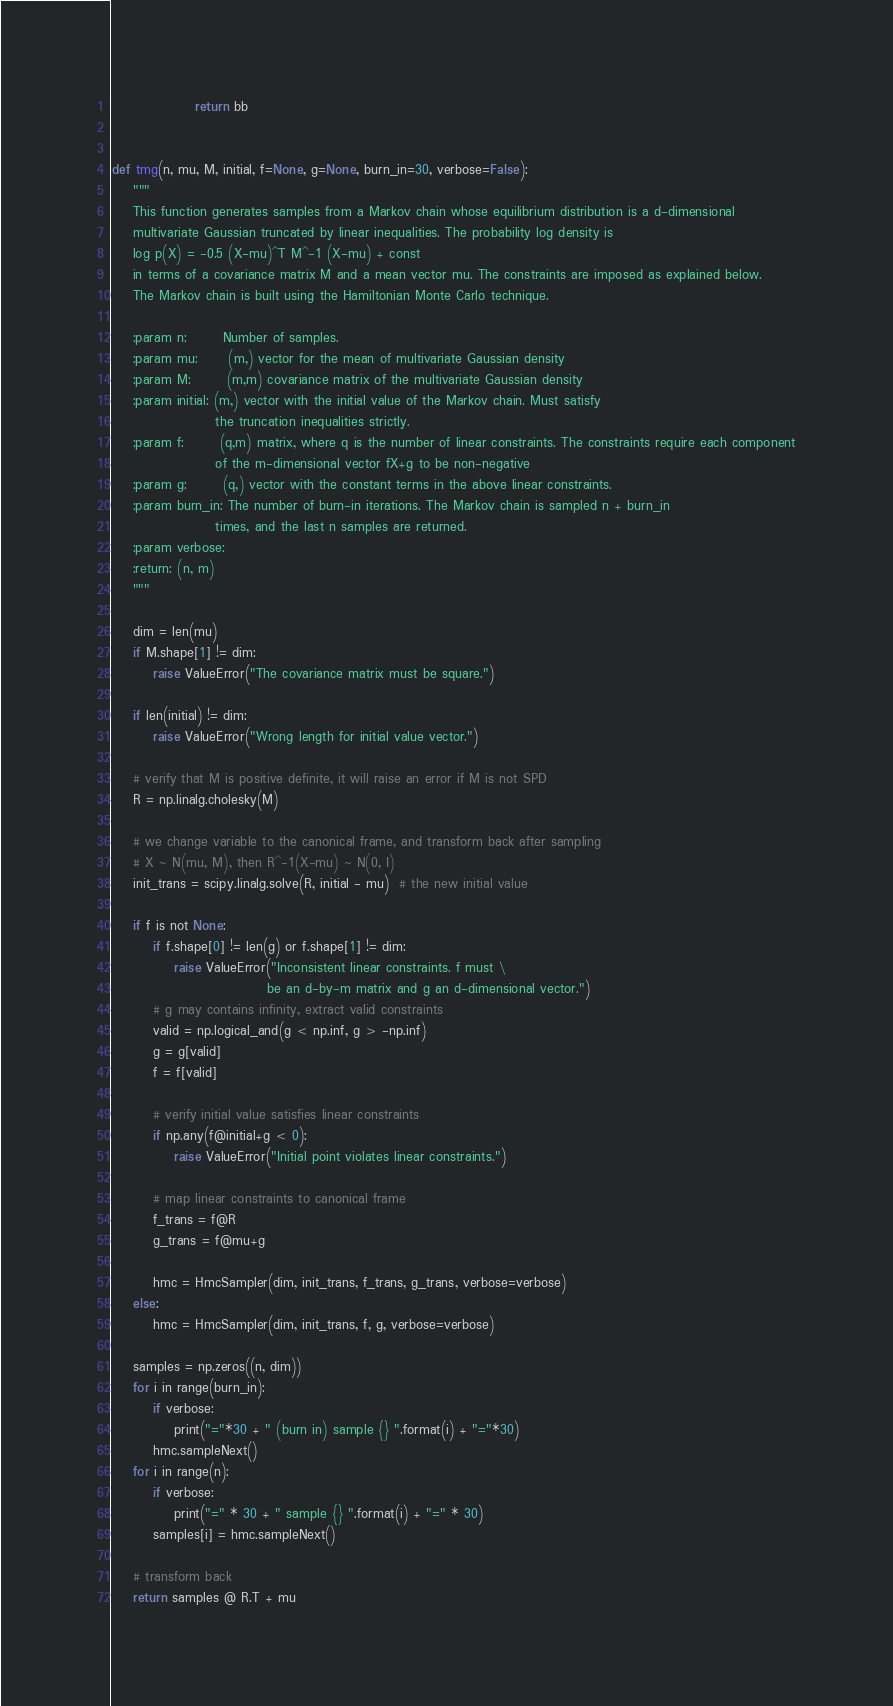<code> <loc_0><loc_0><loc_500><loc_500><_Python_>                return bb


def tmg(n, mu, M, initial, f=None, g=None, burn_in=30, verbose=False):
    """
    This function generates samples from a Markov chain whose equilibrium distribution is a d-dimensional
    multivariate Gaussian truncated by linear inequalities. The probability log density is
    log p(X) = -0.5 (X-mu)^T M^-1 (X-mu) + const
    in terms of a covariance matrix M and a mean vector mu. The constraints are imposed as explained below.
    The Markov chain is built using the Hamiltonian Monte Carlo technique.

    :param n:       Number of samples.
    :param mu:      (m,) vector for the mean of multivariate Gaussian density
    :param M:       (m,m) covariance matrix of the multivariate Gaussian density
    :param initial: (m,) vector with the initial value of the Markov chain. Must satisfy
                    the truncation inequalities strictly.
    :param f:       (q,m) matrix, where q is the number of linear constraints. The constraints require each component
                    of the m-dimensional vector fX+g to be non-negative
    :param g:       (q,) vector with the constant terms in the above linear constraints.
    :param burn_in: The number of burn-in iterations. The Markov chain is sampled n + burn_in
                    times, and the last n samples are returned.
    :param verbose:
    :return: (n, m)
    """

    dim = len(mu)
    if M.shape[1] != dim:
        raise ValueError("The covariance matrix must be square.")

    if len(initial) != dim:
        raise ValueError("Wrong length for initial value vector.")

    # verify that M is positive definite, it will raise an error if M is not SPD
    R = np.linalg.cholesky(M)

    # we change variable to the canonical frame, and transform back after sampling
    # X ~ N(mu, M), then R^-1(X-mu) ~ N(0, I)
    init_trans = scipy.linalg.solve(R, initial - mu)  # the new initial value

    if f is not None:
        if f.shape[0] != len(g) or f.shape[1] != dim:
            raise ValueError("Inconsistent linear constraints. f must \
                              be an d-by-m matrix and g an d-dimensional vector.")
        # g may contains infinity, extract valid constraints
        valid = np.logical_and(g < np.inf, g > -np.inf)
        g = g[valid]
        f = f[valid]

        # verify initial value satisfies linear constraints
        if np.any(f@initial+g < 0):
            raise ValueError("Initial point violates linear constraints.")

        # map linear constraints to canonical frame
        f_trans = f@R
        g_trans = f@mu+g

        hmc = HmcSampler(dim, init_trans, f_trans, g_trans, verbose=verbose)
    else:
        hmc = HmcSampler(dim, init_trans, f, g, verbose=verbose)

    samples = np.zeros((n, dim))
    for i in range(burn_in):
        if verbose:
            print("="*30 + " (burn in) sample {} ".format(i) + "="*30)
        hmc.sampleNext()
    for i in range(n):
        if verbose:
            print("=" * 30 + " sample {} ".format(i) + "=" * 30)
        samples[i] = hmc.sampleNext()

    # transform back
    return samples @ R.T + mu
</code> 